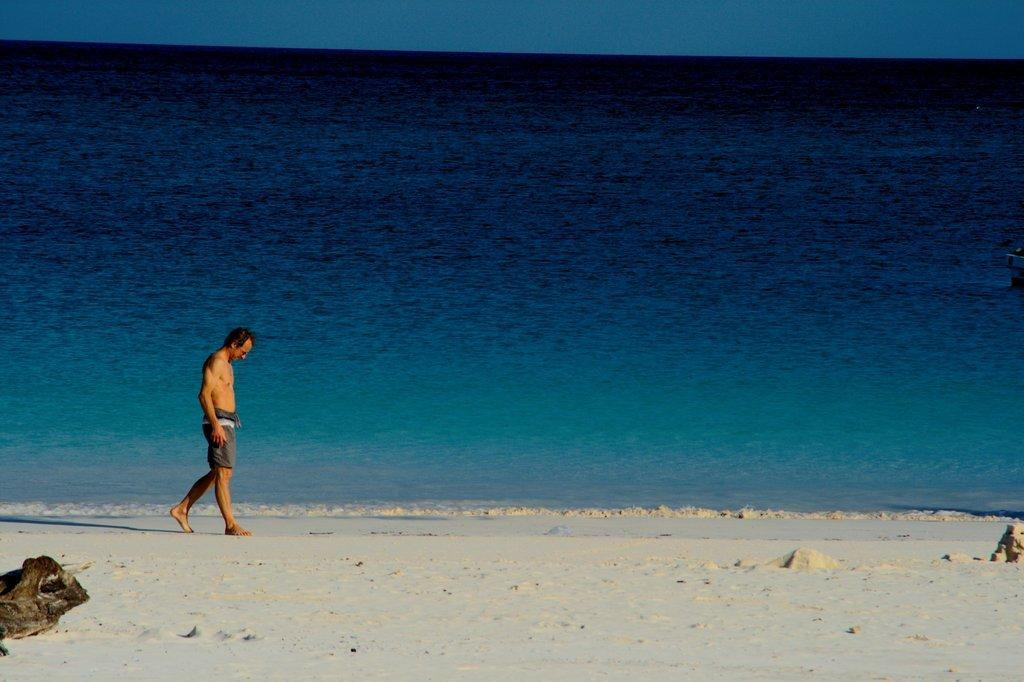What is the person in the image doing? The person is walking in the image. Where is the person walking? The person is walking on the sea shore. What can be seen in the background of the image? There is water and the sky visible in the background of the image. What type of knife is the person using to stir the soup in the image? There is no knife or soup present in the image; the person is walking on the sea shore. 